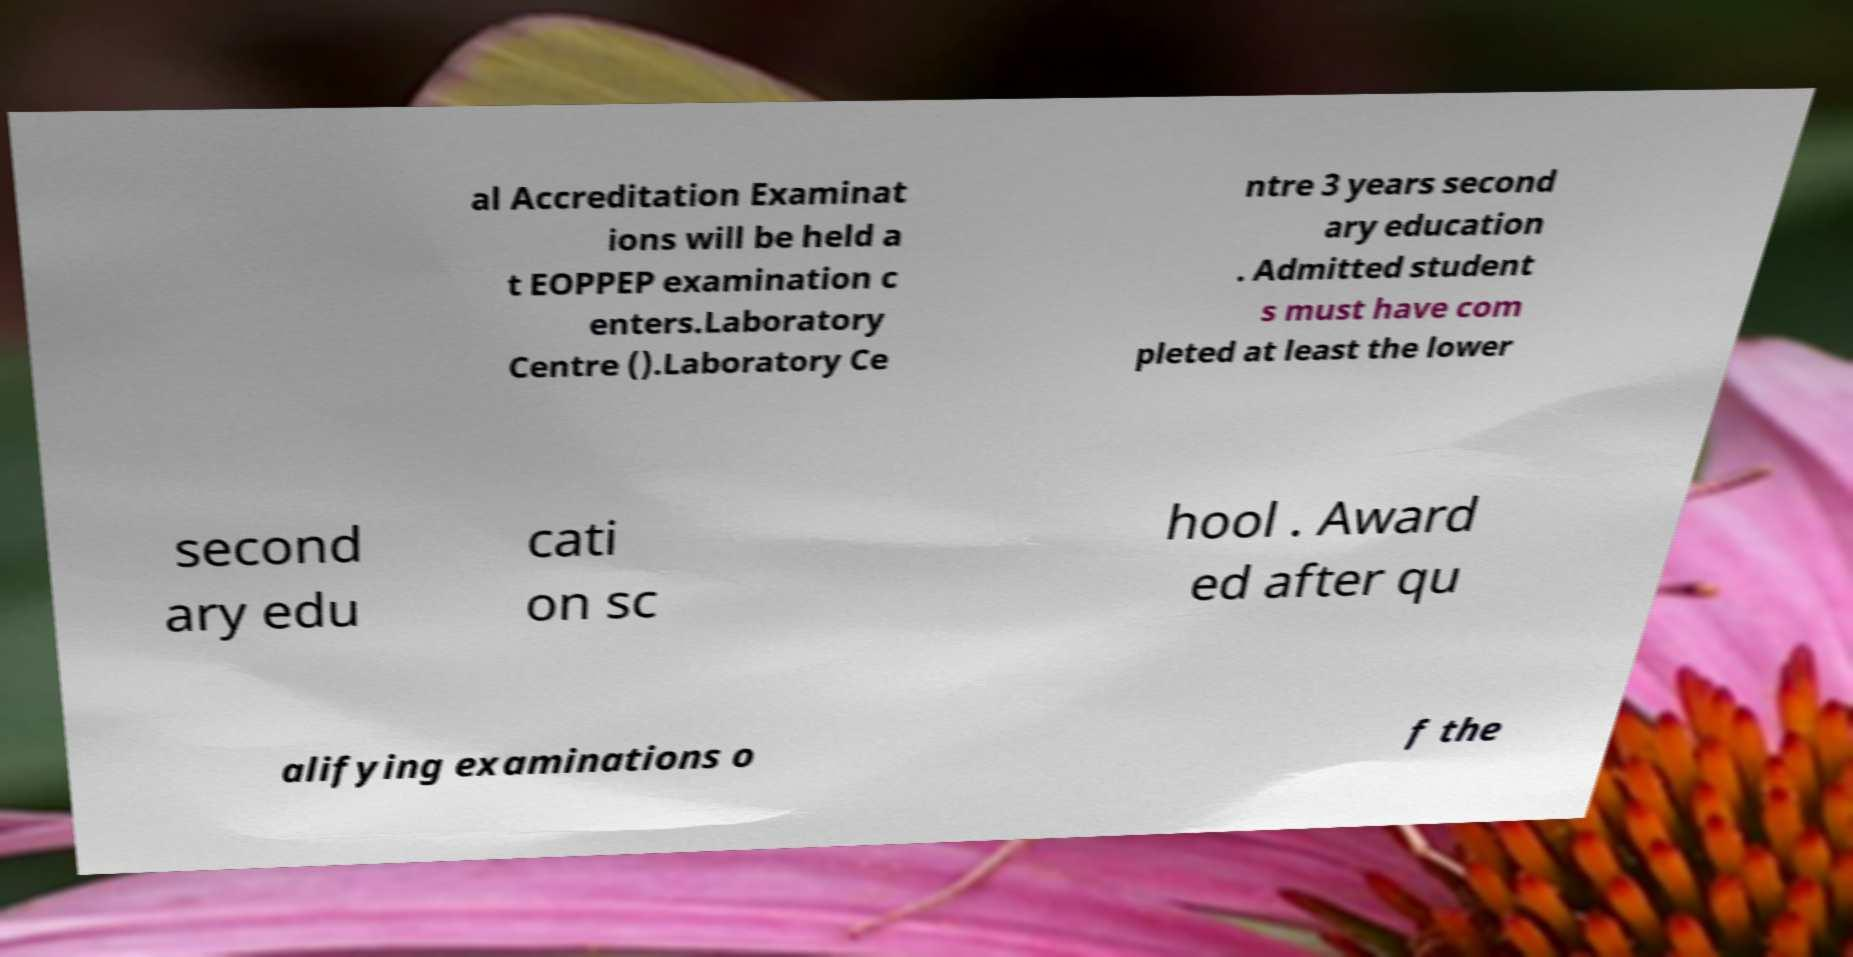Can you read and provide the text displayed in the image?This photo seems to have some interesting text. Can you extract and type it out for me? al Accreditation Examinat ions will be held a t EOPPEP examination c enters.Laboratory Centre ().Laboratory Ce ntre 3 years second ary education . Admitted student s must have com pleted at least the lower second ary edu cati on sc hool . Award ed after qu alifying examinations o f the 